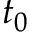<formula> <loc_0><loc_0><loc_500><loc_500>t _ { 0 }</formula> 